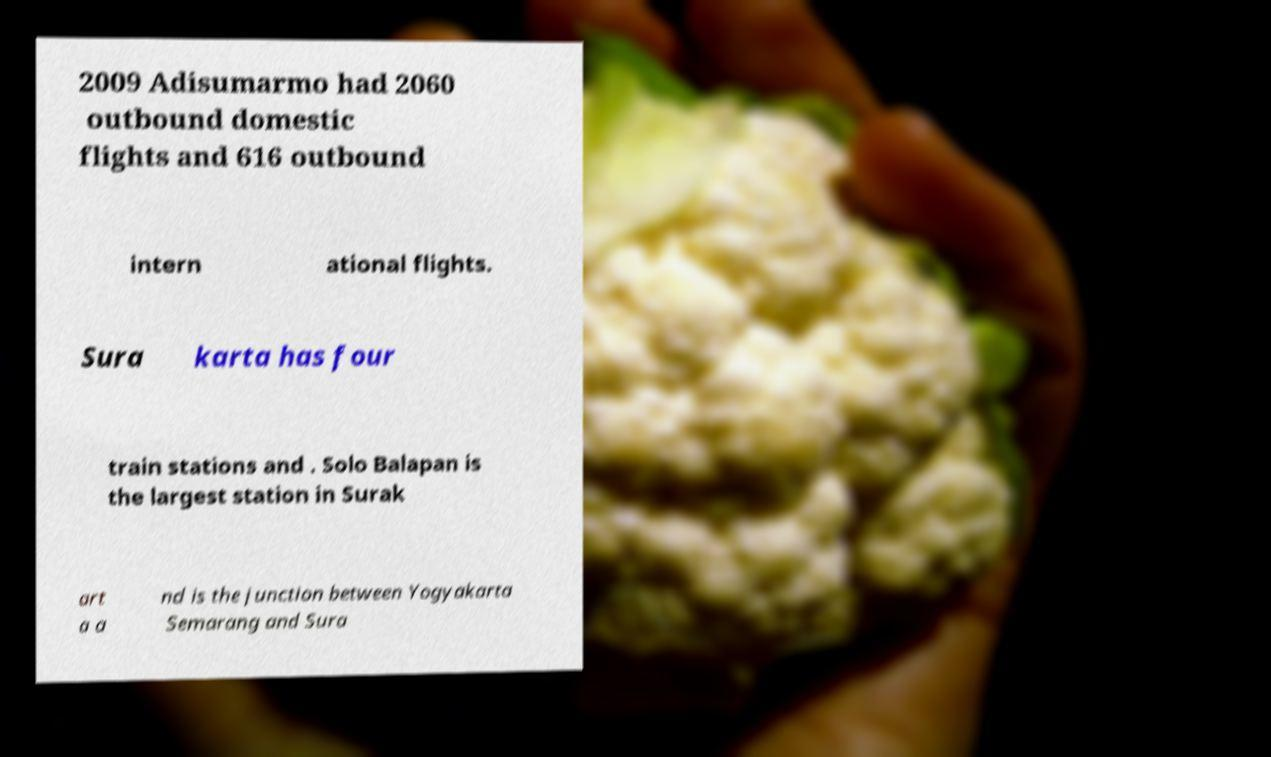Could you assist in decoding the text presented in this image and type it out clearly? 2009 Adisumarmo had 2060 outbound domestic flights and 616 outbound intern ational flights. Sura karta has four train stations and . Solo Balapan is the largest station in Surak art a a nd is the junction between Yogyakarta Semarang and Sura 